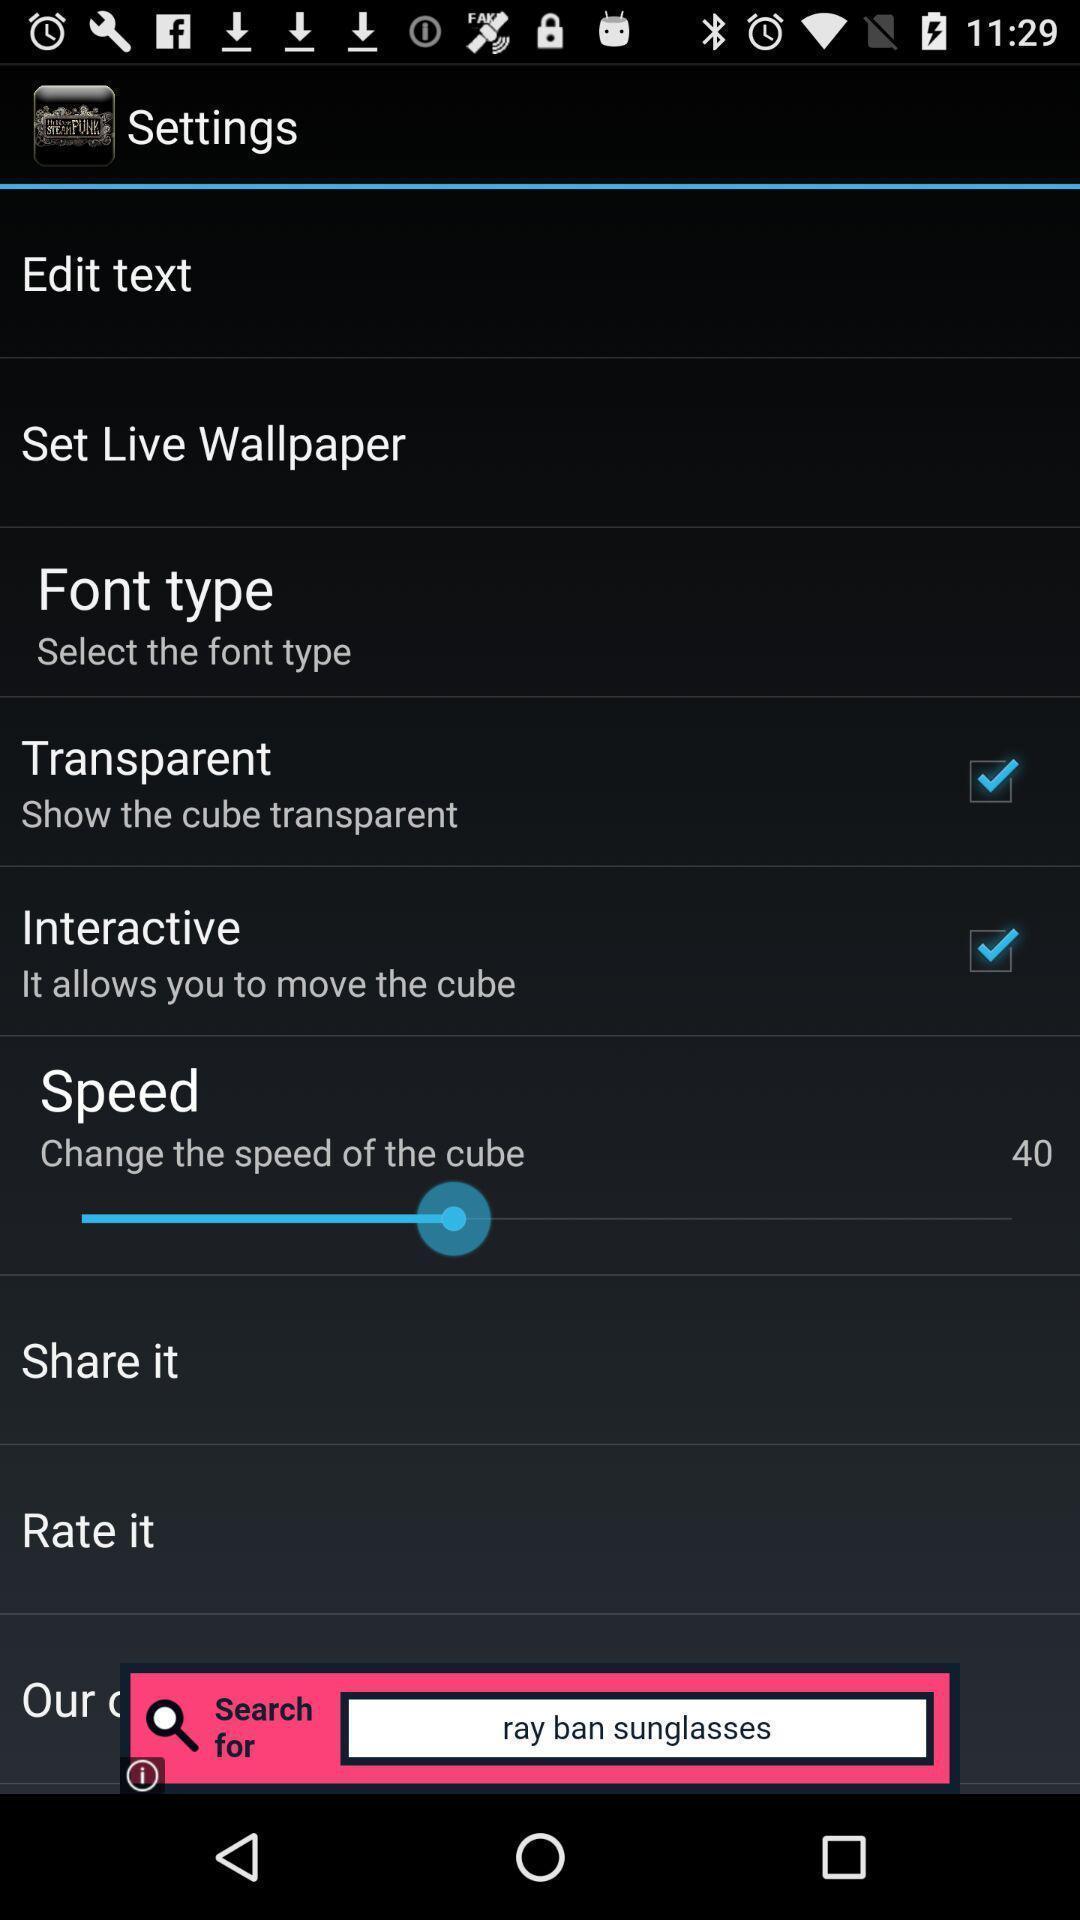Tell me what you see in this picture. Settings page displayed. 